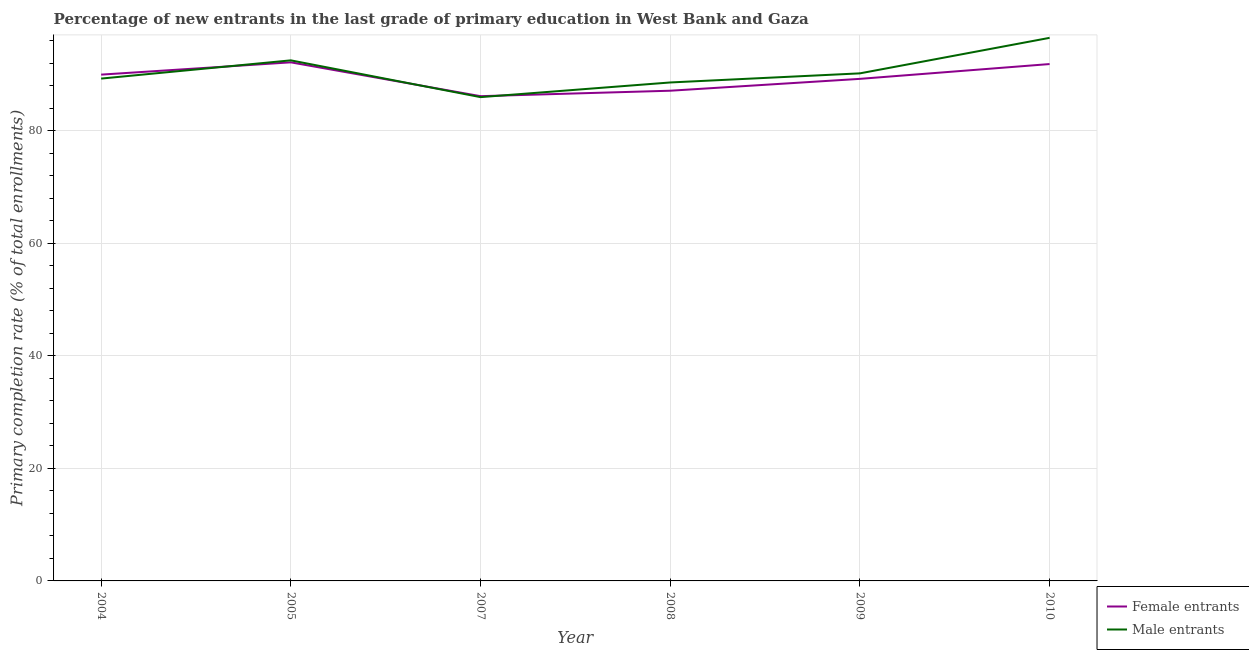What is the primary completion rate of female entrants in 2010?
Offer a terse response. 91.88. Across all years, what is the maximum primary completion rate of female entrants?
Make the answer very short. 92.18. Across all years, what is the minimum primary completion rate of female entrants?
Make the answer very short. 86.17. In which year was the primary completion rate of female entrants maximum?
Keep it short and to the point. 2005. What is the total primary completion rate of male entrants in the graph?
Your response must be concise. 543.19. What is the difference between the primary completion rate of female entrants in 2004 and that in 2009?
Your answer should be very brief. 0.75. What is the difference between the primary completion rate of male entrants in 2008 and the primary completion rate of female entrants in 2010?
Your response must be concise. -3.27. What is the average primary completion rate of male entrants per year?
Provide a succinct answer. 90.53. In the year 2004, what is the difference between the primary completion rate of male entrants and primary completion rate of female entrants?
Ensure brevity in your answer.  -0.7. In how many years, is the primary completion rate of male entrants greater than 56 %?
Give a very brief answer. 6. What is the ratio of the primary completion rate of female entrants in 2009 to that in 2010?
Offer a terse response. 0.97. Is the primary completion rate of female entrants in 2004 less than that in 2008?
Your response must be concise. No. What is the difference between the highest and the second highest primary completion rate of female entrants?
Your response must be concise. 0.3. What is the difference between the highest and the lowest primary completion rate of female entrants?
Offer a very short reply. 6.01. In how many years, is the primary completion rate of female entrants greater than the average primary completion rate of female entrants taken over all years?
Your answer should be compact. 3. Is the primary completion rate of female entrants strictly greater than the primary completion rate of male entrants over the years?
Offer a terse response. No. Is the primary completion rate of female entrants strictly less than the primary completion rate of male entrants over the years?
Keep it short and to the point. No. How many lines are there?
Make the answer very short. 2. Where does the legend appear in the graph?
Your response must be concise. Bottom right. How many legend labels are there?
Provide a succinct answer. 2. What is the title of the graph?
Your response must be concise. Percentage of new entrants in the last grade of primary education in West Bank and Gaza. Does "Taxes" appear as one of the legend labels in the graph?
Offer a terse response. No. What is the label or title of the Y-axis?
Offer a terse response. Primary completion rate (% of total enrollments). What is the Primary completion rate (% of total enrollments) in Female entrants in 2004?
Your answer should be very brief. 90. What is the Primary completion rate (% of total enrollments) of Male entrants in 2004?
Provide a succinct answer. 89.29. What is the Primary completion rate (% of total enrollments) in Female entrants in 2005?
Your answer should be compact. 92.18. What is the Primary completion rate (% of total enrollments) of Male entrants in 2005?
Offer a terse response. 92.54. What is the Primary completion rate (% of total enrollments) in Female entrants in 2007?
Ensure brevity in your answer.  86.17. What is the Primary completion rate (% of total enrollments) in Male entrants in 2007?
Offer a terse response. 86. What is the Primary completion rate (% of total enrollments) of Female entrants in 2008?
Make the answer very short. 87.14. What is the Primary completion rate (% of total enrollments) of Male entrants in 2008?
Your response must be concise. 88.6. What is the Primary completion rate (% of total enrollments) in Female entrants in 2009?
Make the answer very short. 89.25. What is the Primary completion rate (% of total enrollments) in Male entrants in 2009?
Keep it short and to the point. 90.22. What is the Primary completion rate (% of total enrollments) in Female entrants in 2010?
Give a very brief answer. 91.88. What is the Primary completion rate (% of total enrollments) of Male entrants in 2010?
Your answer should be compact. 96.54. Across all years, what is the maximum Primary completion rate (% of total enrollments) in Female entrants?
Offer a terse response. 92.18. Across all years, what is the maximum Primary completion rate (% of total enrollments) in Male entrants?
Your answer should be very brief. 96.54. Across all years, what is the minimum Primary completion rate (% of total enrollments) of Female entrants?
Make the answer very short. 86.17. Across all years, what is the minimum Primary completion rate (% of total enrollments) of Male entrants?
Your response must be concise. 86. What is the total Primary completion rate (% of total enrollments) in Female entrants in the graph?
Your answer should be very brief. 536.61. What is the total Primary completion rate (% of total enrollments) of Male entrants in the graph?
Keep it short and to the point. 543.19. What is the difference between the Primary completion rate (% of total enrollments) in Female entrants in 2004 and that in 2005?
Make the answer very short. -2.18. What is the difference between the Primary completion rate (% of total enrollments) in Male entrants in 2004 and that in 2005?
Your response must be concise. -3.24. What is the difference between the Primary completion rate (% of total enrollments) in Female entrants in 2004 and that in 2007?
Make the answer very short. 3.83. What is the difference between the Primary completion rate (% of total enrollments) in Male entrants in 2004 and that in 2007?
Give a very brief answer. 3.3. What is the difference between the Primary completion rate (% of total enrollments) of Female entrants in 2004 and that in 2008?
Provide a short and direct response. 2.86. What is the difference between the Primary completion rate (% of total enrollments) of Male entrants in 2004 and that in 2008?
Your answer should be very brief. 0.69. What is the difference between the Primary completion rate (% of total enrollments) in Female entrants in 2004 and that in 2009?
Make the answer very short. 0.75. What is the difference between the Primary completion rate (% of total enrollments) in Male entrants in 2004 and that in 2009?
Your answer should be very brief. -0.93. What is the difference between the Primary completion rate (% of total enrollments) of Female entrants in 2004 and that in 2010?
Your answer should be very brief. -1.88. What is the difference between the Primary completion rate (% of total enrollments) of Male entrants in 2004 and that in 2010?
Your response must be concise. -7.24. What is the difference between the Primary completion rate (% of total enrollments) of Female entrants in 2005 and that in 2007?
Offer a very short reply. 6.01. What is the difference between the Primary completion rate (% of total enrollments) in Male entrants in 2005 and that in 2007?
Offer a very short reply. 6.54. What is the difference between the Primary completion rate (% of total enrollments) in Female entrants in 2005 and that in 2008?
Your answer should be compact. 5.04. What is the difference between the Primary completion rate (% of total enrollments) of Male entrants in 2005 and that in 2008?
Your answer should be very brief. 3.93. What is the difference between the Primary completion rate (% of total enrollments) of Female entrants in 2005 and that in 2009?
Your answer should be compact. 2.94. What is the difference between the Primary completion rate (% of total enrollments) of Male entrants in 2005 and that in 2009?
Provide a succinct answer. 2.31. What is the difference between the Primary completion rate (% of total enrollments) of Female entrants in 2005 and that in 2010?
Offer a terse response. 0.3. What is the difference between the Primary completion rate (% of total enrollments) in Male entrants in 2005 and that in 2010?
Provide a short and direct response. -4. What is the difference between the Primary completion rate (% of total enrollments) of Female entrants in 2007 and that in 2008?
Give a very brief answer. -0.97. What is the difference between the Primary completion rate (% of total enrollments) in Male entrants in 2007 and that in 2008?
Keep it short and to the point. -2.61. What is the difference between the Primary completion rate (% of total enrollments) in Female entrants in 2007 and that in 2009?
Offer a very short reply. -3.08. What is the difference between the Primary completion rate (% of total enrollments) in Male entrants in 2007 and that in 2009?
Offer a terse response. -4.23. What is the difference between the Primary completion rate (% of total enrollments) of Female entrants in 2007 and that in 2010?
Make the answer very short. -5.71. What is the difference between the Primary completion rate (% of total enrollments) in Male entrants in 2007 and that in 2010?
Give a very brief answer. -10.54. What is the difference between the Primary completion rate (% of total enrollments) of Female entrants in 2008 and that in 2009?
Offer a very short reply. -2.11. What is the difference between the Primary completion rate (% of total enrollments) in Male entrants in 2008 and that in 2009?
Give a very brief answer. -1.62. What is the difference between the Primary completion rate (% of total enrollments) of Female entrants in 2008 and that in 2010?
Give a very brief answer. -4.74. What is the difference between the Primary completion rate (% of total enrollments) in Male entrants in 2008 and that in 2010?
Your response must be concise. -7.93. What is the difference between the Primary completion rate (% of total enrollments) in Female entrants in 2009 and that in 2010?
Keep it short and to the point. -2.63. What is the difference between the Primary completion rate (% of total enrollments) in Male entrants in 2009 and that in 2010?
Make the answer very short. -6.31. What is the difference between the Primary completion rate (% of total enrollments) in Female entrants in 2004 and the Primary completion rate (% of total enrollments) in Male entrants in 2005?
Provide a succinct answer. -2.54. What is the difference between the Primary completion rate (% of total enrollments) in Female entrants in 2004 and the Primary completion rate (% of total enrollments) in Male entrants in 2007?
Ensure brevity in your answer.  4. What is the difference between the Primary completion rate (% of total enrollments) in Female entrants in 2004 and the Primary completion rate (% of total enrollments) in Male entrants in 2008?
Offer a terse response. 1.39. What is the difference between the Primary completion rate (% of total enrollments) in Female entrants in 2004 and the Primary completion rate (% of total enrollments) in Male entrants in 2009?
Your answer should be very brief. -0.22. What is the difference between the Primary completion rate (% of total enrollments) of Female entrants in 2004 and the Primary completion rate (% of total enrollments) of Male entrants in 2010?
Your answer should be compact. -6.54. What is the difference between the Primary completion rate (% of total enrollments) of Female entrants in 2005 and the Primary completion rate (% of total enrollments) of Male entrants in 2007?
Offer a very short reply. 6.18. What is the difference between the Primary completion rate (% of total enrollments) of Female entrants in 2005 and the Primary completion rate (% of total enrollments) of Male entrants in 2008?
Your answer should be very brief. 3.58. What is the difference between the Primary completion rate (% of total enrollments) of Female entrants in 2005 and the Primary completion rate (% of total enrollments) of Male entrants in 2009?
Your answer should be very brief. 1.96. What is the difference between the Primary completion rate (% of total enrollments) of Female entrants in 2005 and the Primary completion rate (% of total enrollments) of Male entrants in 2010?
Keep it short and to the point. -4.35. What is the difference between the Primary completion rate (% of total enrollments) of Female entrants in 2007 and the Primary completion rate (% of total enrollments) of Male entrants in 2008?
Ensure brevity in your answer.  -2.44. What is the difference between the Primary completion rate (% of total enrollments) of Female entrants in 2007 and the Primary completion rate (% of total enrollments) of Male entrants in 2009?
Provide a succinct answer. -4.06. What is the difference between the Primary completion rate (% of total enrollments) in Female entrants in 2007 and the Primary completion rate (% of total enrollments) in Male entrants in 2010?
Keep it short and to the point. -10.37. What is the difference between the Primary completion rate (% of total enrollments) in Female entrants in 2008 and the Primary completion rate (% of total enrollments) in Male entrants in 2009?
Your answer should be very brief. -3.09. What is the difference between the Primary completion rate (% of total enrollments) in Female entrants in 2008 and the Primary completion rate (% of total enrollments) in Male entrants in 2010?
Offer a terse response. -9.4. What is the difference between the Primary completion rate (% of total enrollments) of Female entrants in 2009 and the Primary completion rate (% of total enrollments) of Male entrants in 2010?
Your answer should be very brief. -7.29. What is the average Primary completion rate (% of total enrollments) in Female entrants per year?
Offer a very short reply. 89.44. What is the average Primary completion rate (% of total enrollments) in Male entrants per year?
Your response must be concise. 90.53. In the year 2004, what is the difference between the Primary completion rate (% of total enrollments) of Female entrants and Primary completion rate (% of total enrollments) of Male entrants?
Your answer should be compact. 0.7. In the year 2005, what is the difference between the Primary completion rate (% of total enrollments) in Female entrants and Primary completion rate (% of total enrollments) in Male entrants?
Ensure brevity in your answer.  -0.35. In the year 2007, what is the difference between the Primary completion rate (% of total enrollments) in Female entrants and Primary completion rate (% of total enrollments) in Male entrants?
Your answer should be very brief. 0.17. In the year 2008, what is the difference between the Primary completion rate (% of total enrollments) in Female entrants and Primary completion rate (% of total enrollments) in Male entrants?
Keep it short and to the point. -1.47. In the year 2009, what is the difference between the Primary completion rate (% of total enrollments) in Female entrants and Primary completion rate (% of total enrollments) in Male entrants?
Give a very brief answer. -0.98. In the year 2010, what is the difference between the Primary completion rate (% of total enrollments) in Female entrants and Primary completion rate (% of total enrollments) in Male entrants?
Keep it short and to the point. -4.66. What is the ratio of the Primary completion rate (% of total enrollments) of Female entrants in 2004 to that in 2005?
Your answer should be compact. 0.98. What is the ratio of the Primary completion rate (% of total enrollments) of Male entrants in 2004 to that in 2005?
Make the answer very short. 0.96. What is the ratio of the Primary completion rate (% of total enrollments) of Female entrants in 2004 to that in 2007?
Your answer should be compact. 1.04. What is the ratio of the Primary completion rate (% of total enrollments) in Male entrants in 2004 to that in 2007?
Keep it short and to the point. 1.04. What is the ratio of the Primary completion rate (% of total enrollments) in Female entrants in 2004 to that in 2008?
Provide a short and direct response. 1.03. What is the ratio of the Primary completion rate (% of total enrollments) in Female entrants in 2004 to that in 2009?
Provide a short and direct response. 1.01. What is the ratio of the Primary completion rate (% of total enrollments) in Male entrants in 2004 to that in 2009?
Offer a very short reply. 0.99. What is the ratio of the Primary completion rate (% of total enrollments) in Female entrants in 2004 to that in 2010?
Your answer should be very brief. 0.98. What is the ratio of the Primary completion rate (% of total enrollments) of Male entrants in 2004 to that in 2010?
Your response must be concise. 0.93. What is the ratio of the Primary completion rate (% of total enrollments) of Female entrants in 2005 to that in 2007?
Your answer should be very brief. 1.07. What is the ratio of the Primary completion rate (% of total enrollments) in Male entrants in 2005 to that in 2007?
Offer a terse response. 1.08. What is the ratio of the Primary completion rate (% of total enrollments) of Female entrants in 2005 to that in 2008?
Keep it short and to the point. 1.06. What is the ratio of the Primary completion rate (% of total enrollments) in Male entrants in 2005 to that in 2008?
Provide a succinct answer. 1.04. What is the ratio of the Primary completion rate (% of total enrollments) of Female entrants in 2005 to that in 2009?
Keep it short and to the point. 1.03. What is the ratio of the Primary completion rate (% of total enrollments) in Male entrants in 2005 to that in 2009?
Provide a short and direct response. 1.03. What is the ratio of the Primary completion rate (% of total enrollments) in Male entrants in 2005 to that in 2010?
Provide a short and direct response. 0.96. What is the ratio of the Primary completion rate (% of total enrollments) in Female entrants in 2007 to that in 2008?
Your answer should be very brief. 0.99. What is the ratio of the Primary completion rate (% of total enrollments) in Male entrants in 2007 to that in 2008?
Ensure brevity in your answer.  0.97. What is the ratio of the Primary completion rate (% of total enrollments) of Female entrants in 2007 to that in 2009?
Your answer should be compact. 0.97. What is the ratio of the Primary completion rate (% of total enrollments) of Male entrants in 2007 to that in 2009?
Your response must be concise. 0.95. What is the ratio of the Primary completion rate (% of total enrollments) in Female entrants in 2007 to that in 2010?
Ensure brevity in your answer.  0.94. What is the ratio of the Primary completion rate (% of total enrollments) in Male entrants in 2007 to that in 2010?
Ensure brevity in your answer.  0.89. What is the ratio of the Primary completion rate (% of total enrollments) of Female entrants in 2008 to that in 2009?
Offer a very short reply. 0.98. What is the ratio of the Primary completion rate (% of total enrollments) in Male entrants in 2008 to that in 2009?
Ensure brevity in your answer.  0.98. What is the ratio of the Primary completion rate (% of total enrollments) of Female entrants in 2008 to that in 2010?
Your answer should be compact. 0.95. What is the ratio of the Primary completion rate (% of total enrollments) in Male entrants in 2008 to that in 2010?
Your answer should be compact. 0.92. What is the ratio of the Primary completion rate (% of total enrollments) in Female entrants in 2009 to that in 2010?
Ensure brevity in your answer.  0.97. What is the ratio of the Primary completion rate (% of total enrollments) in Male entrants in 2009 to that in 2010?
Give a very brief answer. 0.93. What is the difference between the highest and the second highest Primary completion rate (% of total enrollments) in Female entrants?
Offer a very short reply. 0.3. What is the difference between the highest and the second highest Primary completion rate (% of total enrollments) in Male entrants?
Give a very brief answer. 4. What is the difference between the highest and the lowest Primary completion rate (% of total enrollments) of Female entrants?
Keep it short and to the point. 6.01. What is the difference between the highest and the lowest Primary completion rate (% of total enrollments) of Male entrants?
Your response must be concise. 10.54. 